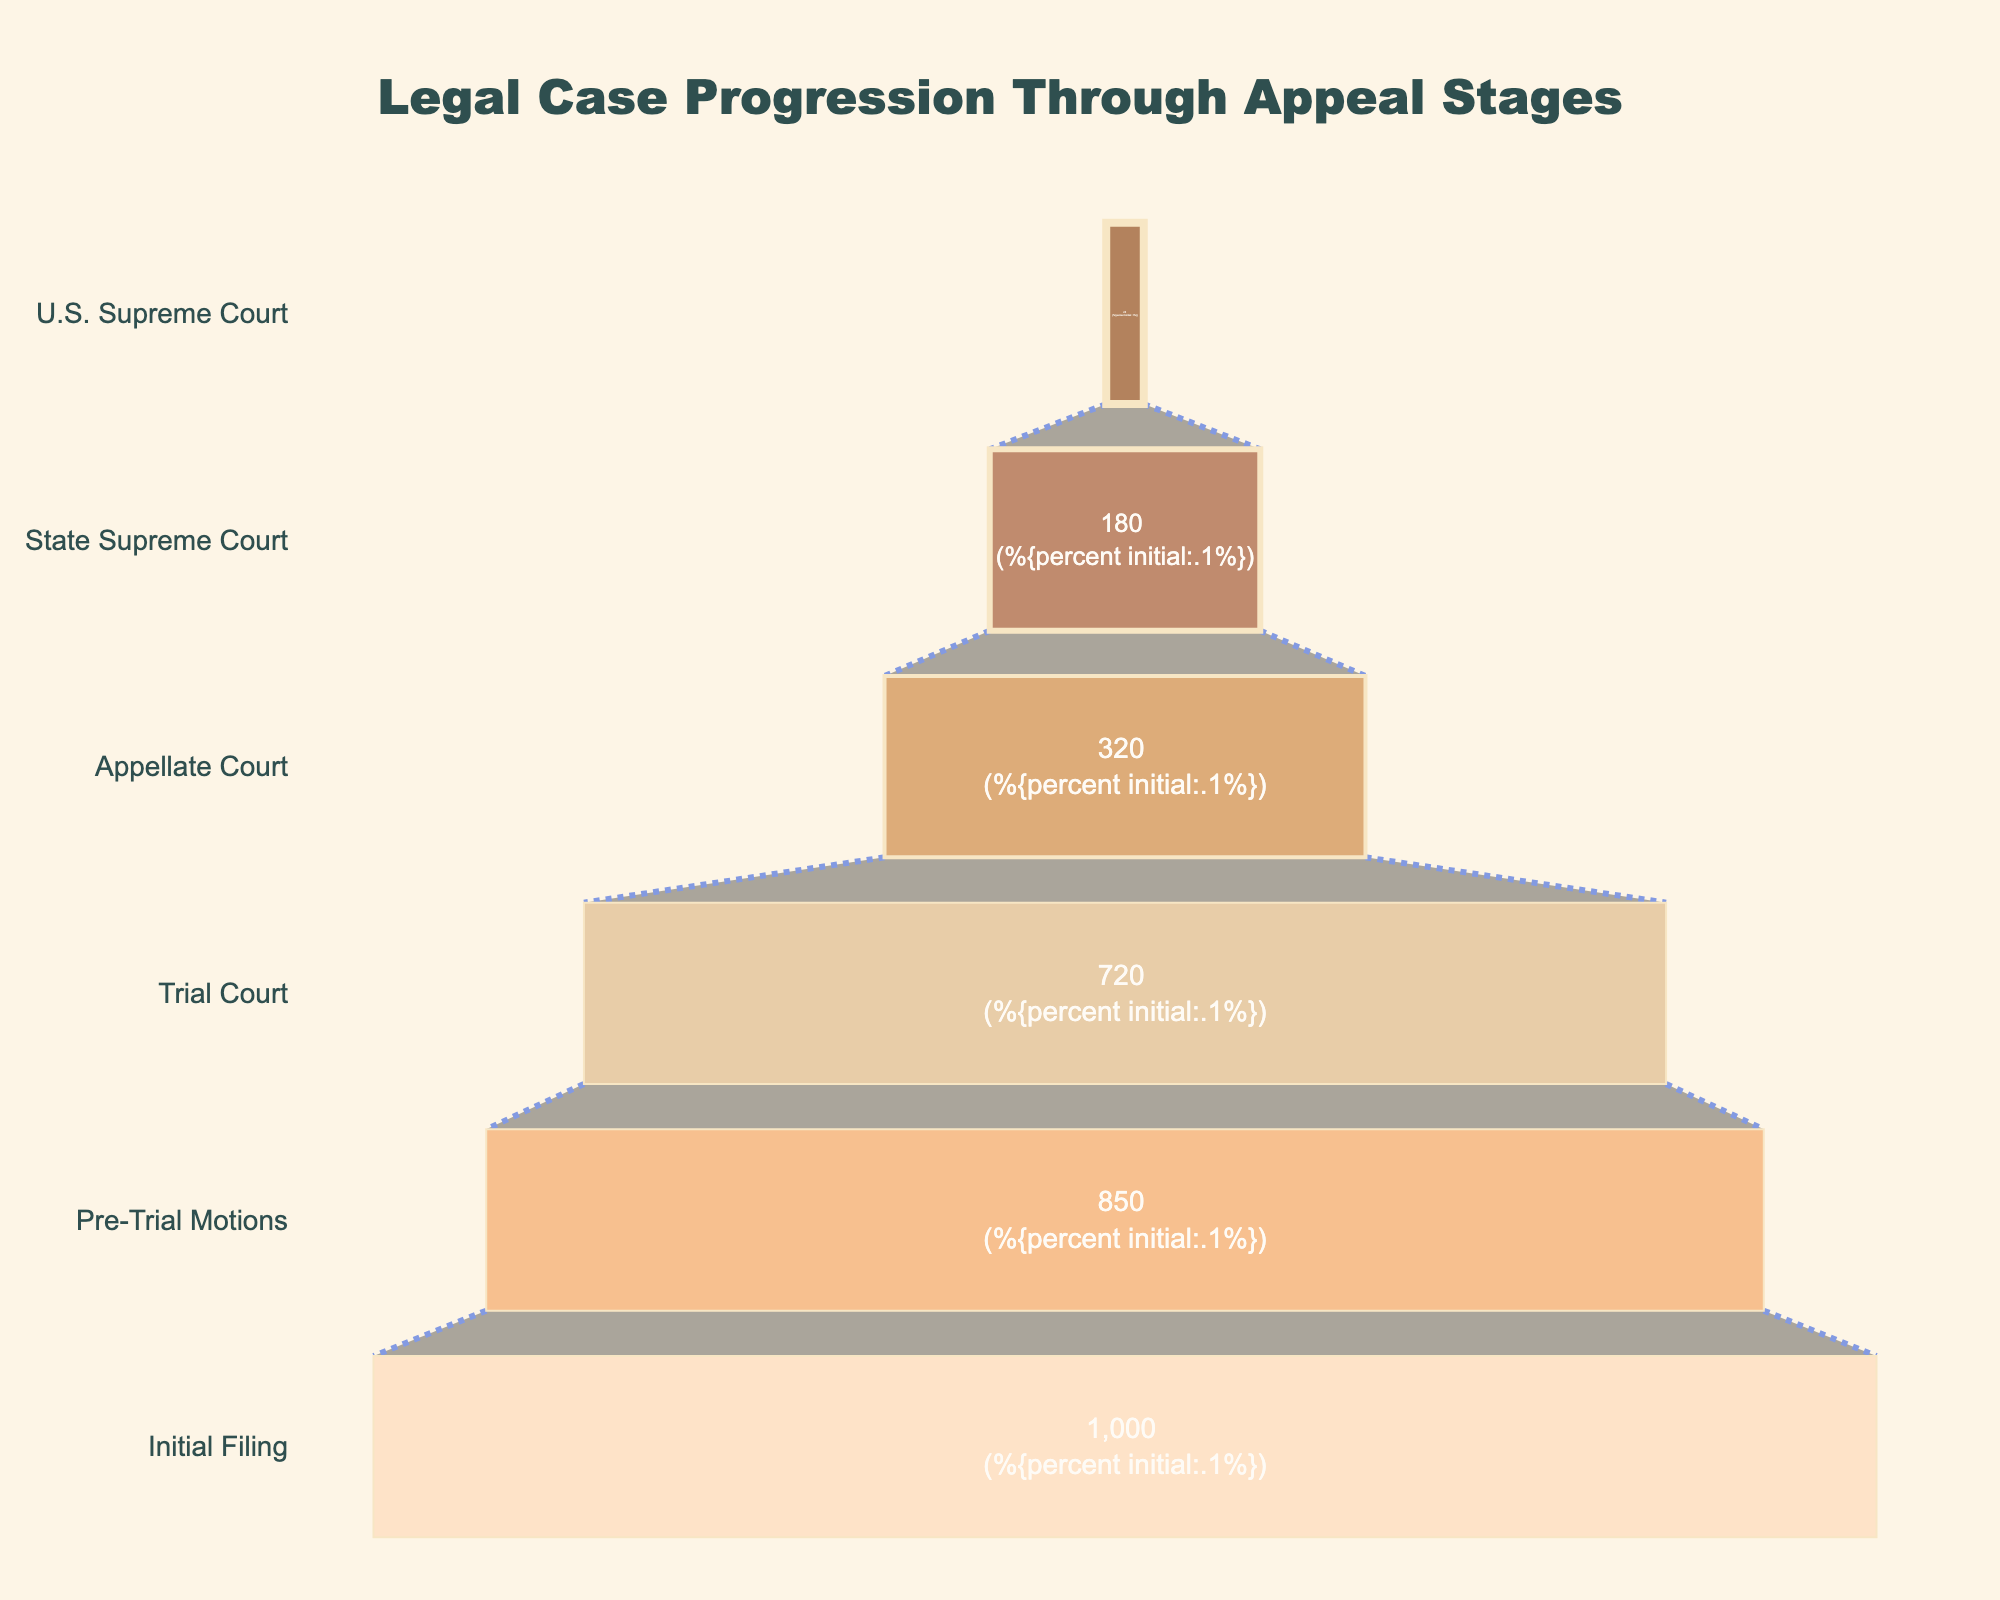What's the title of the funnel chart? The title is located at the top center of the chart.
Answer: Legal Case Progression Through Appeal Stages How many cases reach the U.S. Supreme Court? The chart shows the stages of legal cases with the number of cases in each stage. The number at the U.S. Supreme Court stage is 25.
Answer: 25 What percentage of cases from the initial filing reach the Appellate Court? The text within the Appellate Court section shows the percentage of the initial number of cases that progress to this stage.
Answer: 32% What is the difference in the number of cases between the Trial Court and the State Supreme Court? The chart shows 720 cases in the Trial Court and 180 cases in the State Supreme Court. The difference is 720 - 180.
Answer: 540 Which stage has the second-highest number of cases? By observing the number of cases at each stage, the second-highest number is found in the Pre-Trial Motions with 850 cases.
Answer: Pre-Trial Motions How many stages are there in total in this funnel chart? Counting each stage listed in the vertical funnel reveals a total of six stages.
Answer: 6 What is the approximate percentage drop from the Trial Court to the Appellate Court? From the Trial Court to the Appellate Court, cases drop from 720 to 320. The percentage drop can be calculated as ((720 - 320) / 720) * 100%.
Answer: ~55.6% Which stage sees the largest drop in the number of cases from the previous stage? By observing the changes between each stage, the largest drop is from the Trial Court (720) to the Appellate Court (320).
Answer: Trial Court to Appellate Court How many stages have more than 500 cases? By counting the stages with more than 500 cases, you find Initial Filing (1000), Pre-Trial Motions (850), and Trial Court (720).
Answer: 3 